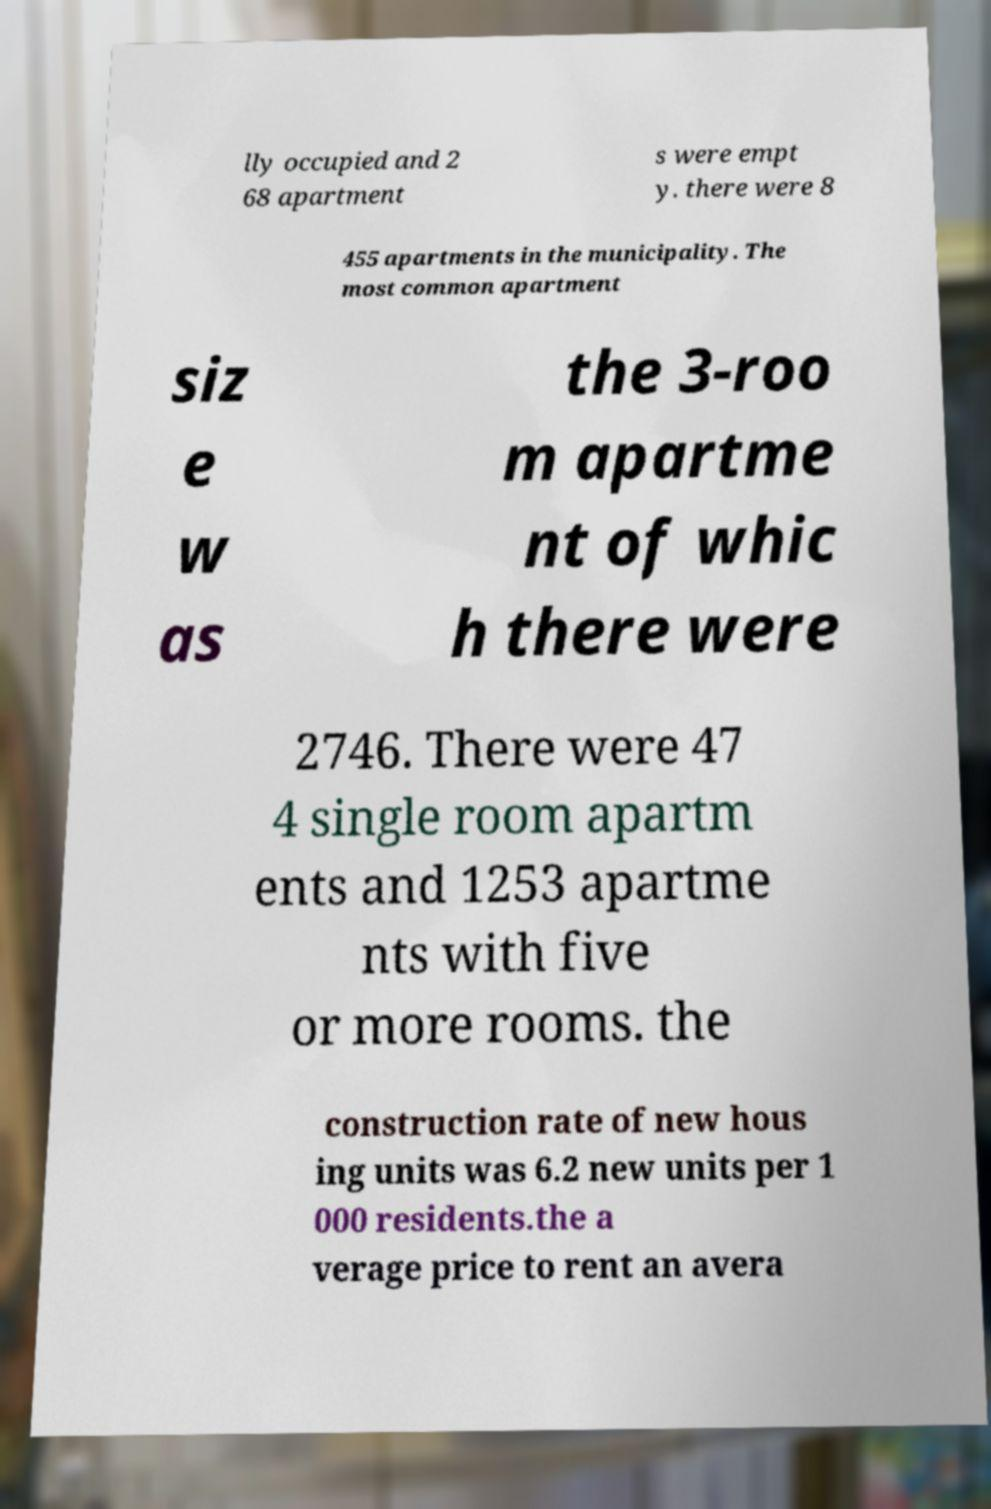Could you extract and type out the text from this image? lly occupied and 2 68 apartment s were empt y. there were 8 455 apartments in the municipality. The most common apartment siz e w as the 3-roo m apartme nt of whic h there were 2746. There were 47 4 single room apartm ents and 1253 apartme nts with five or more rooms. the construction rate of new hous ing units was 6.2 new units per 1 000 residents.the a verage price to rent an avera 